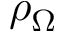<formula> <loc_0><loc_0><loc_500><loc_500>\rho _ { \Omega }</formula> 